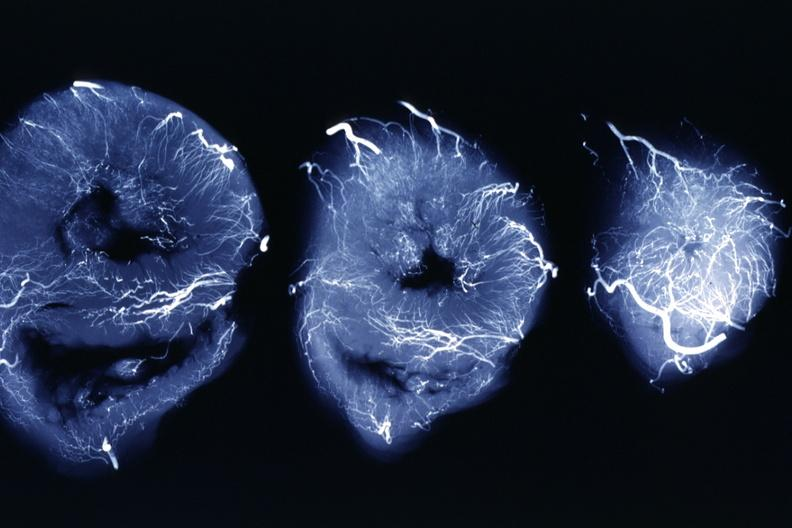what is present?
Answer the question using a single word or phrase. X-ray intramyocardial arteries 